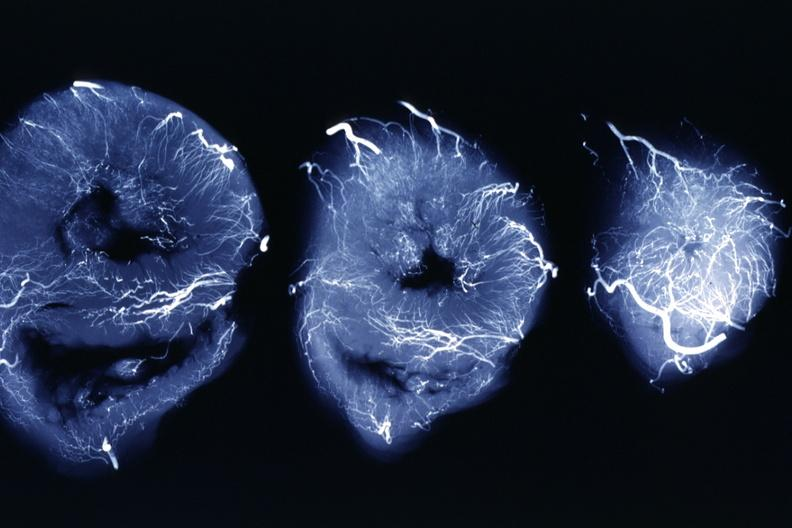what is present?
Answer the question using a single word or phrase. X-ray intramyocardial arteries 